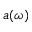Convert formula to latex. <formula><loc_0><loc_0><loc_500><loc_500>a ( \omega )</formula> 